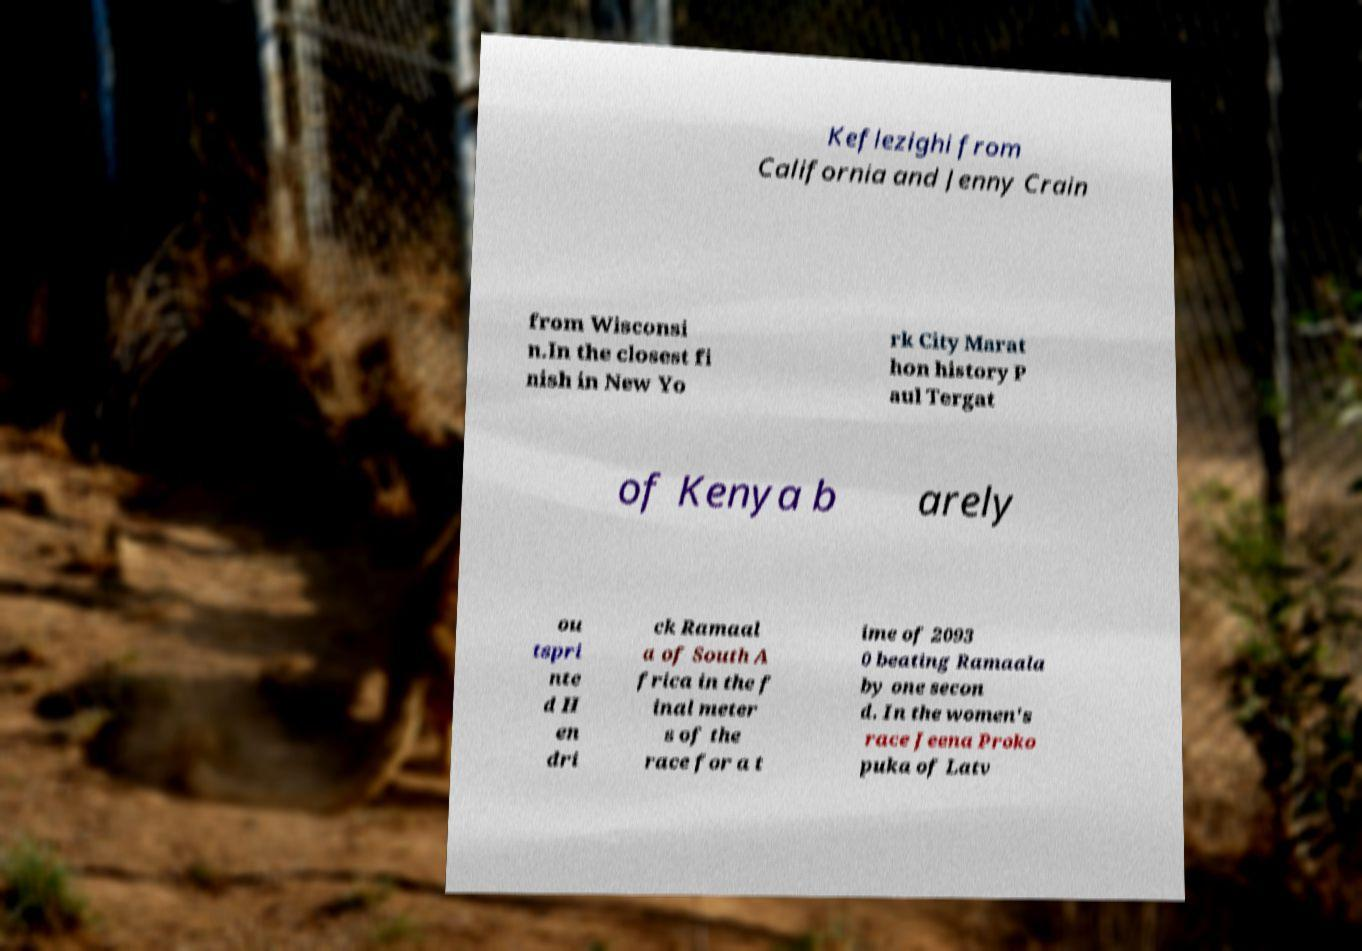For documentation purposes, I need the text within this image transcribed. Could you provide that? Keflezighi from California and Jenny Crain from Wisconsi n.In the closest fi nish in New Yo rk City Marat hon history P aul Tergat of Kenya b arely ou tspri nte d H en dri ck Ramaal a of South A frica in the f inal meter s of the race for a t ime of 2093 0 beating Ramaala by one secon d. In the women's race Jeena Proko puka of Latv 